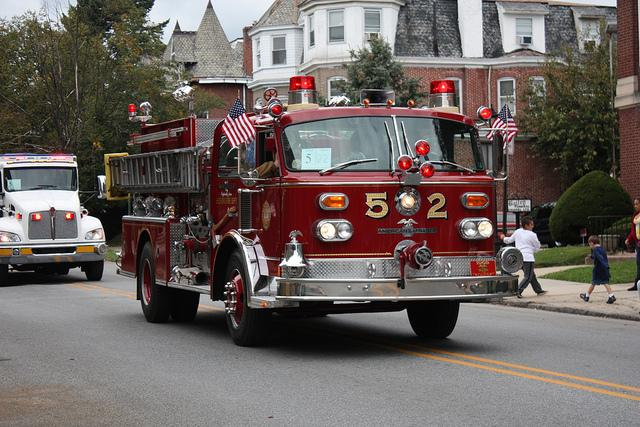What country's flag can be seen on the truck?

Choices:
A) italy
B) america
C) france
D) spain america 